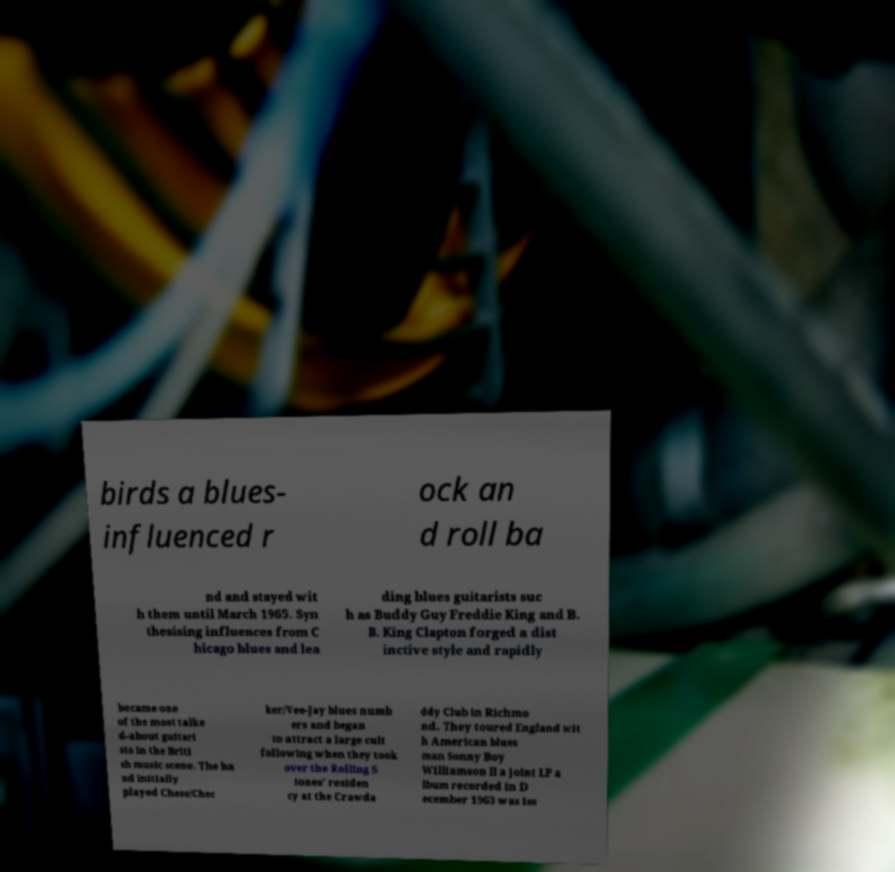Can you accurately transcribe the text from the provided image for me? birds a blues- influenced r ock an d roll ba nd and stayed wit h them until March 1965. Syn thesising influences from C hicago blues and lea ding blues guitarists suc h as Buddy Guy Freddie King and B. B. King Clapton forged a dist inctive style and rapidly became one of the most talke d-about guitari sts in the Briti sh music scene. The ba nd initially played Chess/Chec ker/Vee-Jay blues numb ers and began to attract a large cult following when they took over the Rolling S tones' residen cy at the Crawda ddy Club in Richmo nd. They toured England wit h American blues man Sonny Boy Williamson II a joint LP a lbum recorded in D ecember 1963 was iss 